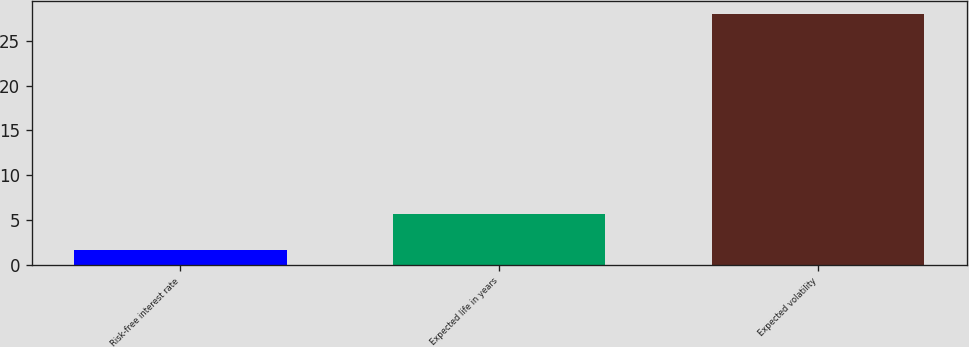Convert chart to OTSL. <chart><loc_0><loc_0><loc_500><loc_500><bar_chart><fcel>Risk-free interest rate<fcel>Expected life in years<fcel>Expected volatility<nl><fcel>1.65<fcel>5.7<fcel>28<nl></chart> 